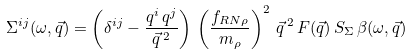<formula> <loc_0><loc_0><loc_500><loc_500>\Sigma ^ { i j } ( \omega , { \vec { q } } ) = \left ( \delta ^ { i j } - \frac { q ^ { i } \, q ^ { j } } { \vec { q } \, ^ { 2 } } \right ) \, \left ( \frac { f _ { R N \rho } } { m _ { \rho } } \right ) ^ { 2 } \, \vec { q } \, ^ { 2 } \, F ( \vec { q } ) \, S _ { \Sigma } \, \beta ( \omega , { \vec { q } } ) \\</formula> 